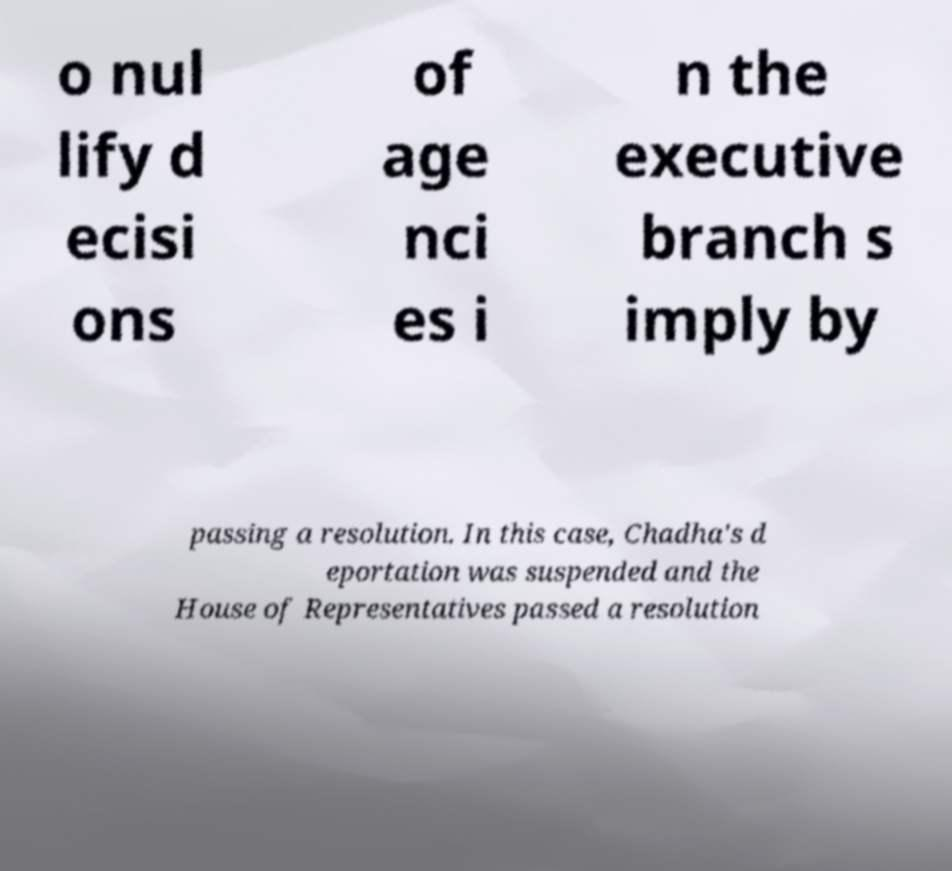Can you read and provide the text displayed in the image?This photo seems to have some interesting text. Can you extract and type it out for me? o nul lify d ecisi ons of age nci es i n the executive branch s imply by passing a resolution. In this case, Chadha's d eportation was suspended and the House of Representatives passed a resolution 